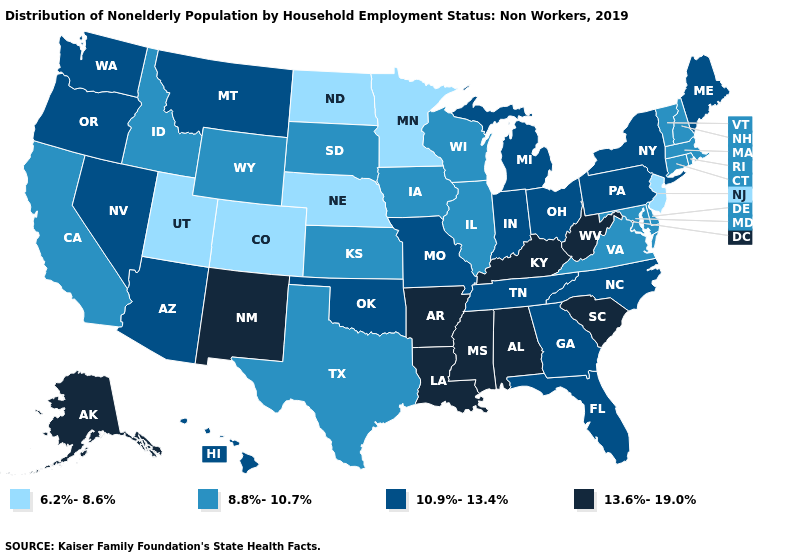Does the map have missing data?
Write a very short answer. No. What is the lowest value in states that border Oklahoma?
Give a very brief answer. 6.2%-8.6%. Name the states that have a value in the range 10.9%-13.4%?
Be succinct. Arizona, Florida, Georgia, Hawaii, Indiana, Maine, Michigan, Missouri, Montana, Nevada, New York, North Carolina, Ohio, Oklahoma, Oregon, Pennsylvania, Tennessee, Washington. Does Utah have the lowest value in the USA?
Short answer required. Yes. Name the states that have a value in the range 6.2%-8.6%?
Write a very short answer. Colorado, Minnesota, Nebraska, New Jersey, North Dakota, Utah. Among the states that border Missouri , which have the lowest value?
Short answer required. Nebraska. Does Delaware have the lowest value in the South?
Keep it brief. Yes. What is the value of New York?
Be succinct. 10.9%-13.4%. What is the lowest value in states that border Maine?
Keep it brief. 8.8%-10.7%. What is the highest value in the MidWest ?
Give a very brief answer. 10.9%-13.4%. What is the value of Illinois?
Answer briefly. 8.8%-10.7%. What is the value of Connecticut?
Keep it brief. 8.8%-10.7%. What is the value of Minnesota?
Quick response, please. 6.2%-8.6%. Which states have the lowest value in the USA?
Keep it brief. Colorado, Minnesota, Nebraska, New Jersey, North Dakota, Utah. Which states have the lowest value in the USA?
Write a very short answer. Colorado, Minnesota, Nebraska, New Jersey, North Dakota, Utah. 